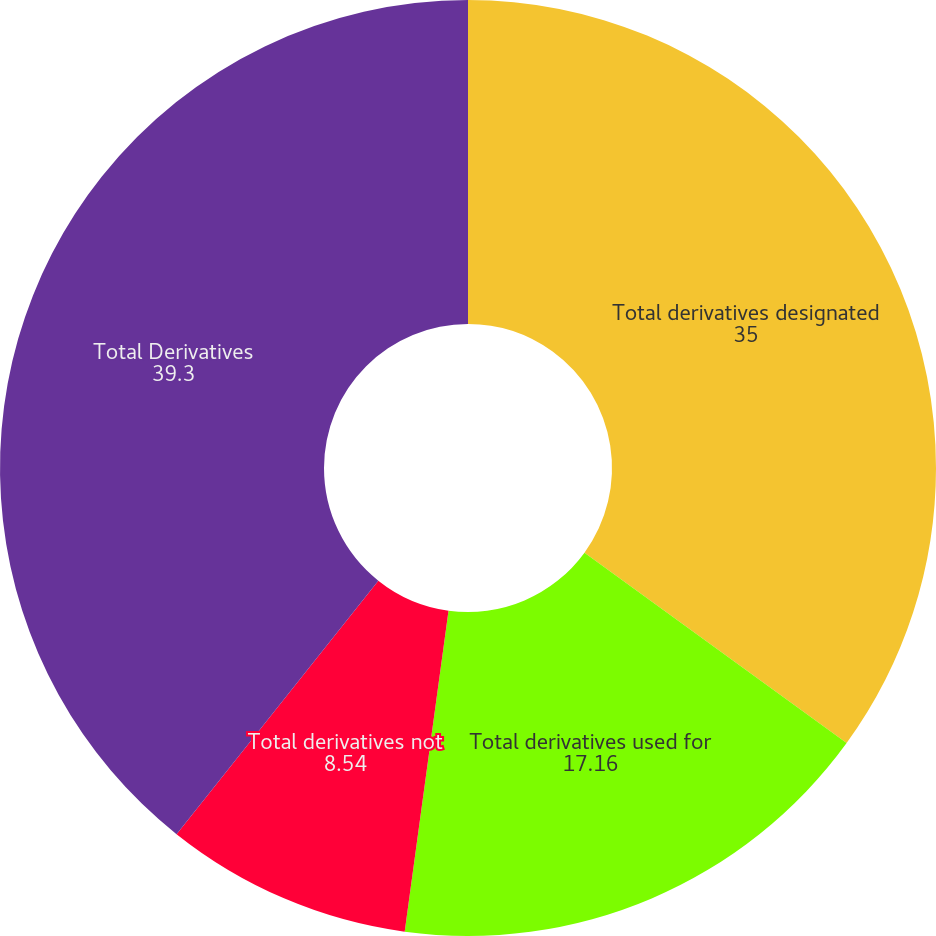<chart> <loc_0><loc_0><loc_500><loc_500><pie_chart><fcel>Total derivatives designated<fcel>Total derivatives used for<fcel>Total derivatives not<fcel>Total Derivatives<nl><fcel>35.0%<fcel>17.16%<fcel>8.54%<fcel>39.3%<nl></chart> 